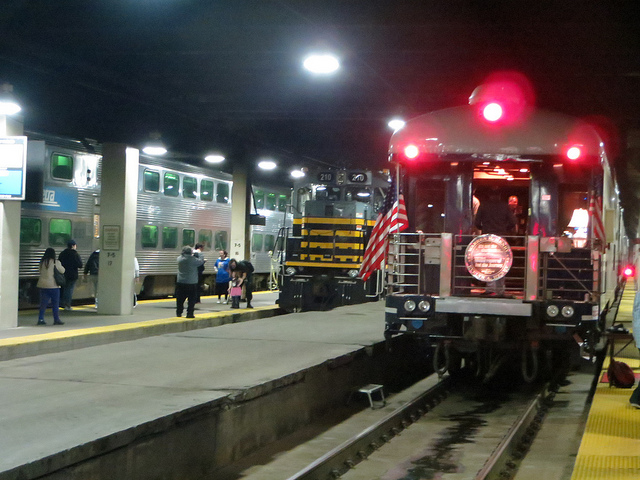<image>How many people are in the front of the train? I am not sure. It can be 0 or 8. How many people are in the front of the train? There are no people in the front of the train. 